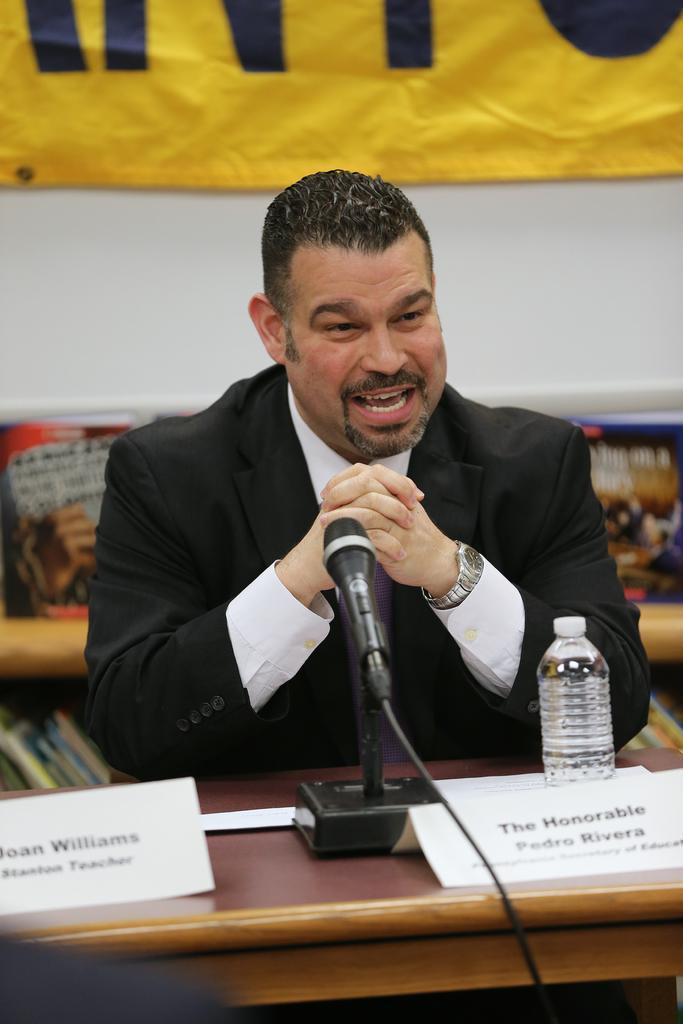Could you give a brief overview of what you see in this image? In the image, there is a brown color table on which a mic is placed and also a bottle in front of that a person wearing black color coat is sitting ,he is speaking, in the background there is a yellow color banner and white color wall. 